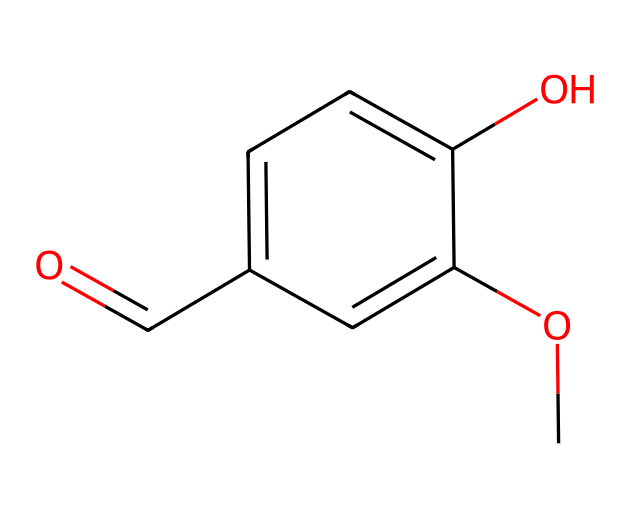What is the common name of this chemical? The structure corresponds to vanillin, which is a well-known compound recognized for its vanilla aroma and commonly associated with flavoring in food, particularly in desserts like gelato.
Answer: vanillin How many carbon atoms are in the structure? Counting the carbon atoms in the SMILES, there are eight carbon atoms (C). The skeleton structure can be seen to have multiple carbon atoms connected together.
Answer: 8 What functional group is present in this molecule? The structure contains both a carbonyl (aldehyde) group indicated by "O=C" and a hydroxyl (-OH) group attached to an aromatic ring, identifying it as an aromatic aldehyde.
Answer: aldehyde How many hydrogen atoms are attached to the carbon atoms? For hydrogen atoms, each carbon generally takes four bonds; tallying the aromatic system plus the hydroxyl and the aldehyde leads to a total of eight hydrogen atoms in the SMILES representation.
Answer: 8 What type of aroma does this compound produce? Vanillin is primarily known to have a sweet, creamy vanilla aroma, which is particularly associated with desserts and confections, commonly found in Italian gelato flavors.
Answer: vanilla 